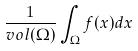<formula> <loc_0><loc_0><loc_500><loc_500>\frac { 1 } { v o l ( \Omega ) } \int _ { \Omega } f ( x ) d x</formula> 